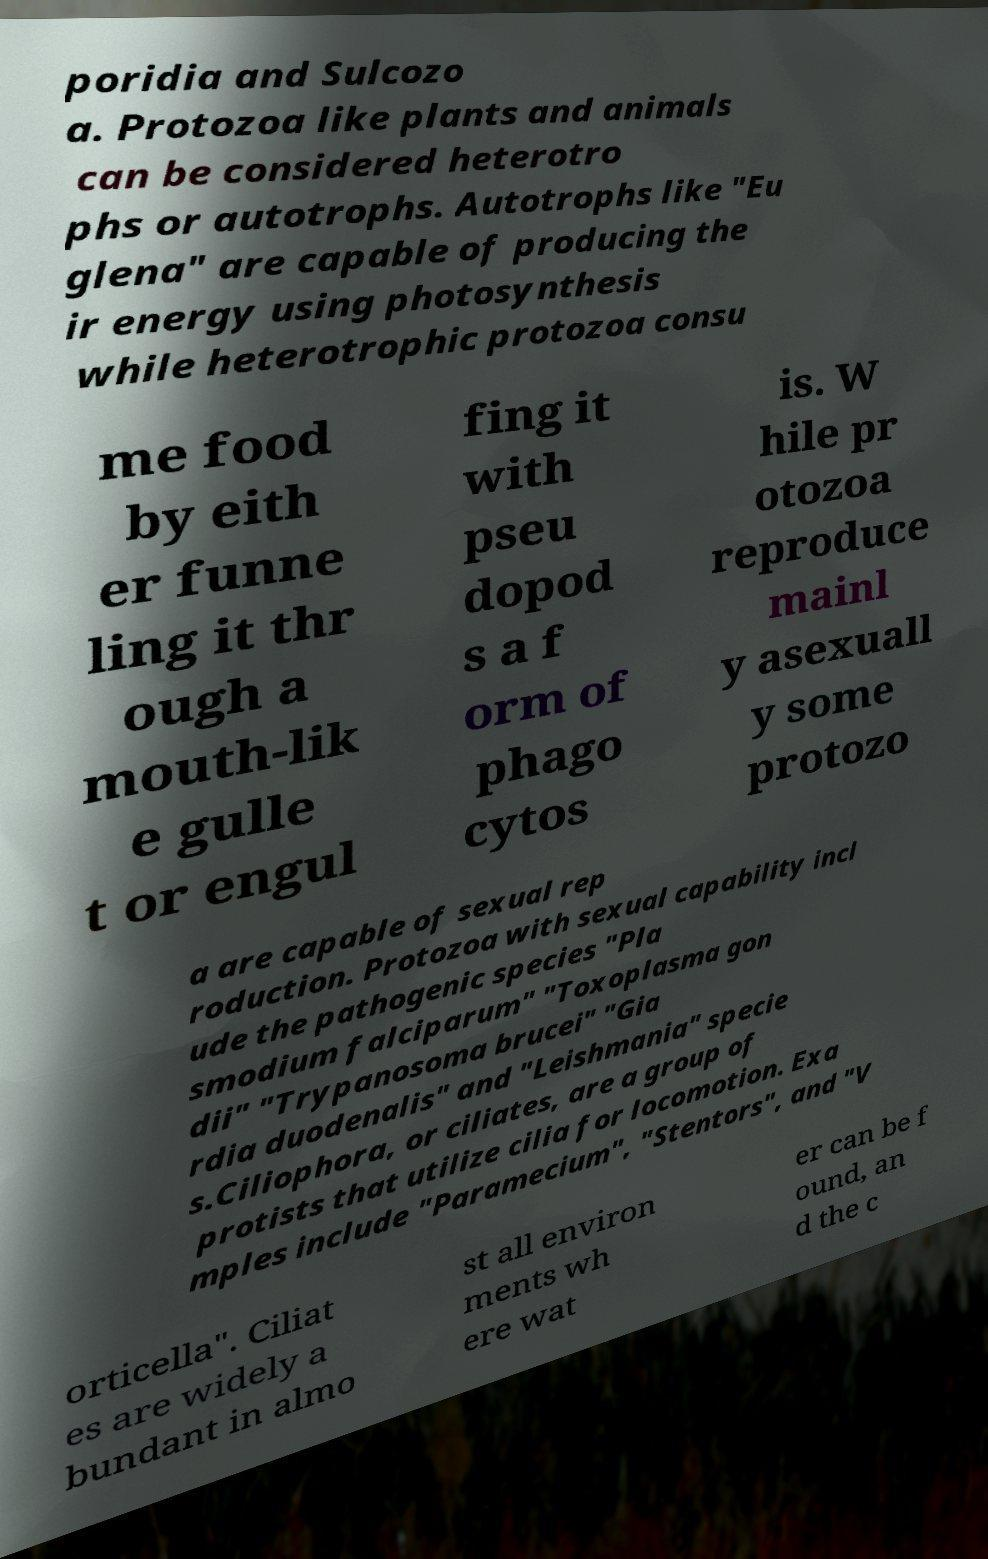Please identify and transcribe the text found in this image. poridia and Sulcozo a. Protozoa like plants and animals can be considered heterotro phs or autotrophs. Autotrophs like "Eu glena" are capable of producing the ir energy using photosynthesis while heterotrophic protozoa consu me food by eith er funne ling it thr ough a mouth-lik e gulle t or engul fing it with pseu dopod s a f orm of phago cytos is. W hile pr otozoa reproduce mainl y asexuall y some protozo a are capable of sexual rep roduction. Protozoa with sexual capability incl ude the pathogenic species "Pla smodium falciparum" "Toxoplasma gon dii" "Trypanosoma brucei" "Gia rdia duodenalis" and "Leishmania" specie s.Ciliophora, or ciliates, are a group of protists that utilize cilia for locomotion. Exa mples include "Paramecium", "Stentors", and "V orticella". Ciliat es are widely a bundant in almo st all environ ments wh ere wat er can be f ound, an d the c 